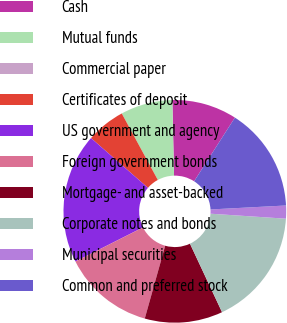Convert chart. <chart><loc_0><loc_0><loc_500><loc_500><pie_chart><fcel>Cash<fcel>Mutual funds<fcel>Commercial paper<fcel>Certificates of deposit<fcel>US government and agency<fcel>Foreign government bonds<fcel>Mortgage- and asset-backed<fcel>Corporate notes and bonds<fcel>Municipal securities<fcel>Common and preferred stock<nl><fcel>9.43%<fcel>7.55%<fcel>0.0%<fcel>5.66%<fcel>18.87%<fcel>13.21%<fcel>11.32%<fcel>16.98%<fcel>1.89%<fcel>15.09%<nl></chart> 